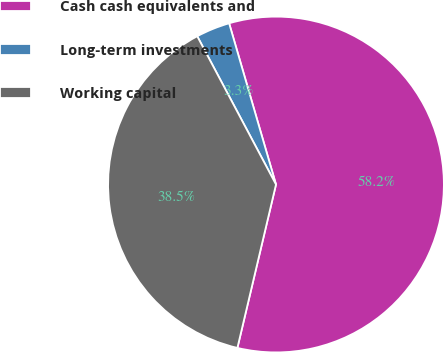<chart> <loc_0><loc_0><loc_500><loc_500><pie_chart><fcel>Cash cash equivalents and<fcel>Long-term investments<fcel>Working capital<nl><fcel>58.2%<fcel>3.27%<fcel>38.54%<nl></chart> 